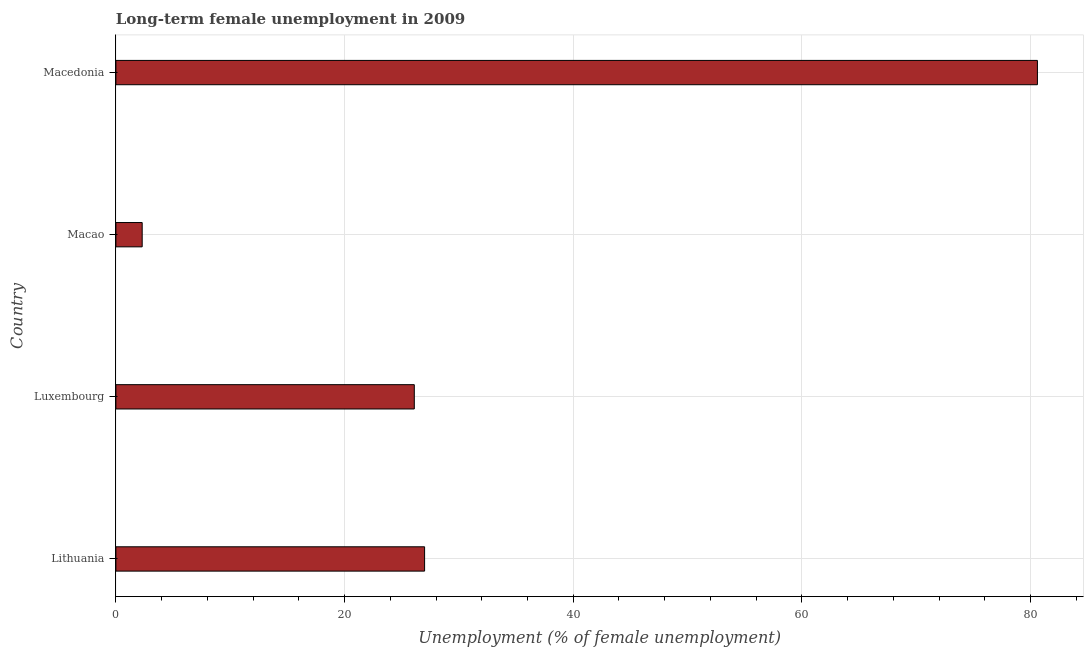What is the title of the graph?
Your answer should be very brief. Long-term female unemployment in 2009. What is the label or title of the X-axis?
Offer a terse response. Unemployment (% of female unemployment). What is the long-term female unemployment in Macao?
Your answer should be compact. 2.3. Across all countries, what is the maximum long-term female unemployment?
Make the answer very short. 80.6. Across all countries, what is the minimum long-term female unemployment?
Provide a succinct answer. 2.3. In which country was the long-term female unemployment maximum?
Provide a succinct answer. Macedonia. In which country was the long-term female unemployment minimum?
Give a very brief answer. Macao. What is the sum of the long-term female unemployment?
Your answer should be very brief. 136. What is the average long-term female unemployment per country?
Offer a terse response. 34. What is the median long-term female unemployment?
Your answer should be very brief. 26.55. What is the ratio of the long-term female unemployment in Luxembourg to that in Macedonia?
Ensure brevity in your answer.  0.32. Is the long-term female unemployment in Luxembourg less than that in Macao?
Make the answer very short. No. What is the difference between the highest and the second highest long-term female unemployment?
Ensure brevity in your answer.  53.6. Is the sum of the long-term female unemployment in Luxembourg and Macao greater than the maximum long-term female unemployment across all countries?
Your answer should be very brief. No. What is the difference between the highest and the lowest long-term female unemployment?
Provide a short and direct response. 78.3. Are all the bars in the graph horizontal?
Your answer should be compact. Yes. What is the difference between two consecutive major ticks on the X-axis?
Your response must be concise. 20. What is the Unemployment (% of female unemployment) of Luxembourg?
Make the answer very short. 26.1. What is the Unemployment (% of female unemployment) of Macao?
Make the answer very short. 2.3. What is the Unemployment (% of female unemployment) of Macedonia?
Keep it short and to the point. 80.6. What is the difference between the Unemployment (% of female unemployment) in Lithuania and Luxembourg?
Your answer should be compact. 0.9. What is the difference between the Unemployment (% of female unemployment) in Lithuania and Macao?
Your answer should be very brief. 24.7. What is the difference between the Unemployment (% of female unemployment) in Lithuania and Macedonia?
Offer a terse response. -53.6. What is the difference between the Unemployment (% of female unemployment) in Luxembourg and Macao?
Ensure brevity in your answer.  23.8. What is the difference between the Unemployment (% of female unemployment) in Luxembourg and Macedonia?
Your answer should be very brief. -54.5. What is the difference between the Unemployment (% of female unemployment) in Macao and Macedonia?
Provide a succinct answer. -78.3. What is the ratio of the Unemployment (% of female unemployment) in Lithuania to that in Luxembourg?
Your answer should be compact. 1.03. What is the ratio of the Unemployment (% of female unemployment) in Lithuania to that in Macao?
Offer a very short reply. 11.74. What is the ratio of the Unemployment (% of female unemployment) in Lithuania to that in Macedonia?
Provide a short and direct response. 0.34. What is the ratio of the Unemployment (% of female unemployment) in Luxembourg to that in Macao?
Provide a succinct answer. 11.35. What is the ratio of the Unemployment (% of female unemployment) in Luxembourg to that in Macedonia?
Keep it short and to the point. 0.32. What is the ratio of the Unemployment (% of female unemployment) in Macao to that in Macedonia?
Ensure brevity in your answer.  0.03. 